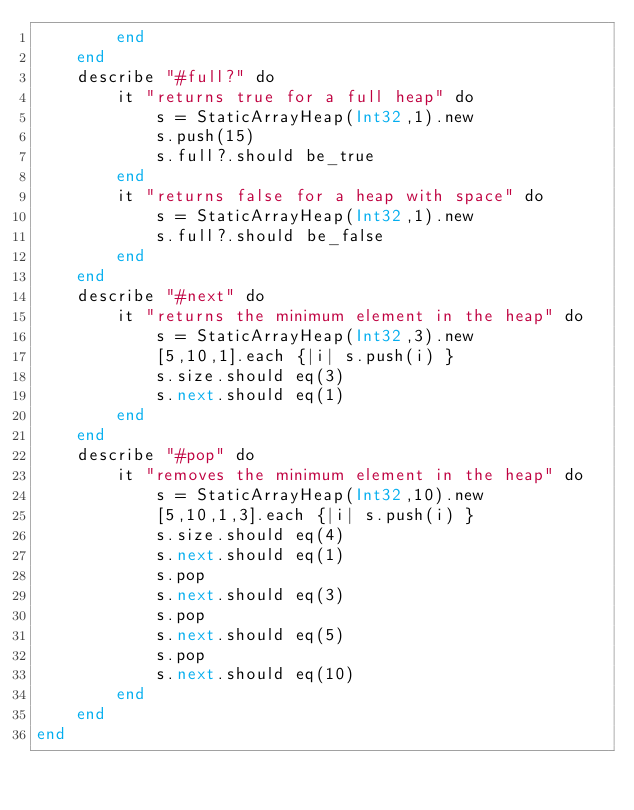Convert code to text. <code><loc_0><loc_0><loc_500><loc_500><_Crystal_>		end
	end
	describe "#full?" do
		it "returns true for a full heap" do
			s = StaticArrayHeap(Int32,1).new
			s.push(15)
			s.full?.should be_true
		end
		it "returns false for a heap with space" do
			s = StaticArrayHeap(Int32,1).new
			s.full?.should be_false
		end
	end
	describe "#next" do
		it "returns the minimum element in the heap" do
			s = StaticArrayHeap(Int32,3).new
			[5,10,1].each {|i| s.push(i) }
			s.size.should eq(3)
			s.next.should eq(1)
		end
	end
	describe "#pop" do
		it "removes the minimum element in the heap" do
			s = StaticArrayHeap(Int32,10).new
			[5,10,1,3].each {|i| s.push(i) }
			s.size.should eq(4)
			s.next.should eq(1)
			s.pop
			s.next.should eq(3)
			s.pop
			s.next.should eq(5)
			s.pop
			s.next.should eq(10)
		end
	end
end
</code> 